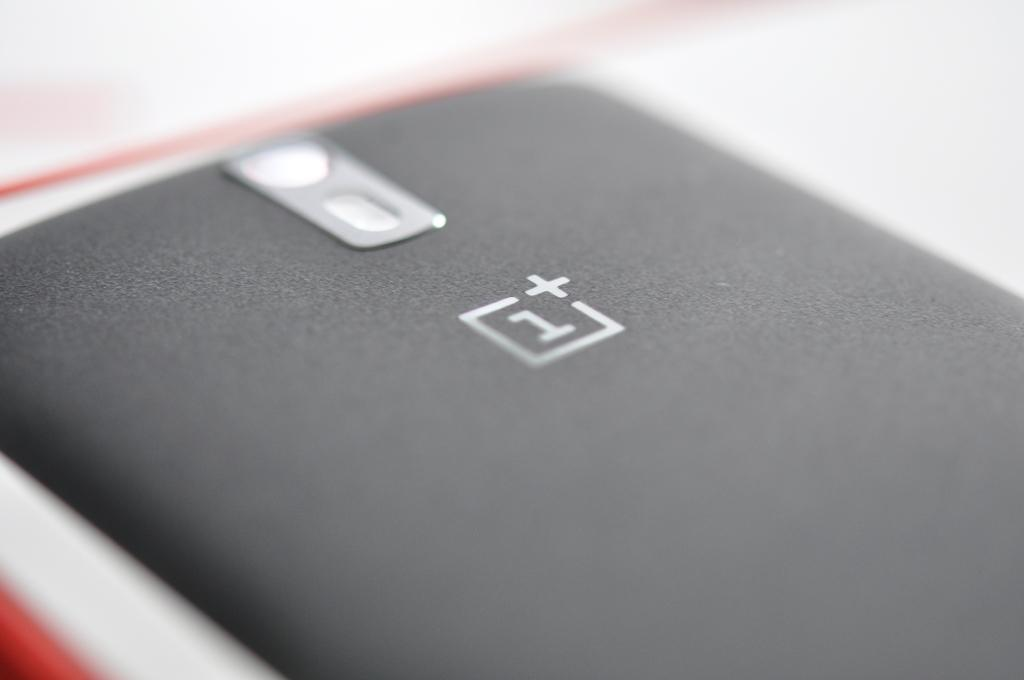<image>
Provide a brief description of the given image. A phone sitting face down with a 1 in a box. 